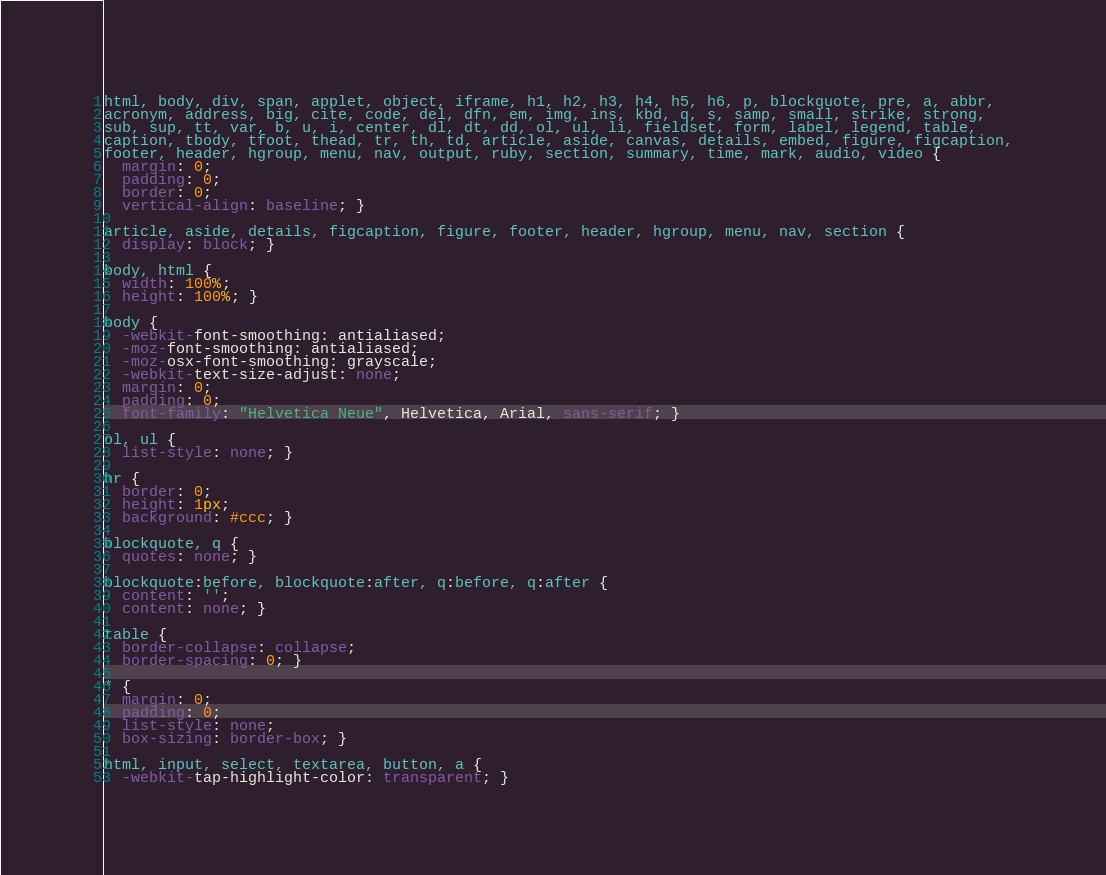<code> <loc_0><loc_0><loc_500><loc_500><_CSS_>html, body, div, span, applet, object, iframe, h1, h2, h3, h4, h5, h6, p, blockquote, pre, a, abbr,
acronym, address, big, cite, code, del, dfn, em, img, ins, kbd, q, s, samp, small, strike, strong,
sub, sup, tt, var, b, u, i, center, dl, dt, dd, ol, ul, li, fieldset, form, label, legend, table,
caption, tbody, tfoot, thead, tr, th, td, article, aside, canvas, details, embed, figure, figcaption,
footer, header, hgroup, menu, nav, output, ruby, section, summary, time, mark, audio, video {
  margin: 0;
  padding: 0;
  border: 0;
  vertical-align: baseline; }

article, aside, details, figcaption, figure, footer, header, hgroup, menu, nav, section {
  display: block; }

body, html {
  width: 100%;
  height: 100%; }

body {
  -webkit-font-smoothing: antialiased;
  -moz-font-smoothing: antialiased;
  -moz-osx-font-smoothing: grayscale;
  -webkit-text-size-adjust: none;
  margin: 0;
  padding: 0;
  font-family: "Helvetica Neue", Helvetica, Arial, sans-serif; }

ol, ul {
  list-style: none; }

hr {
  border: 0;
  height: 1px;
  background: #ccc; }

blockquote, q {
  quotes: none; }

blockquote:before, blockquote:after, q:before, q:after {
  content: '';
  content: none; }

table {
  border-collapse: collapse;
  border-spacing: 0; }

* {
  margin: 0;
  padding: 0;
  list-style: none;
  box-sizing: border-box; }

html, input, select, textarea, button, a {
  -webkit-tap-highlight-color: transparent; }
</code> 